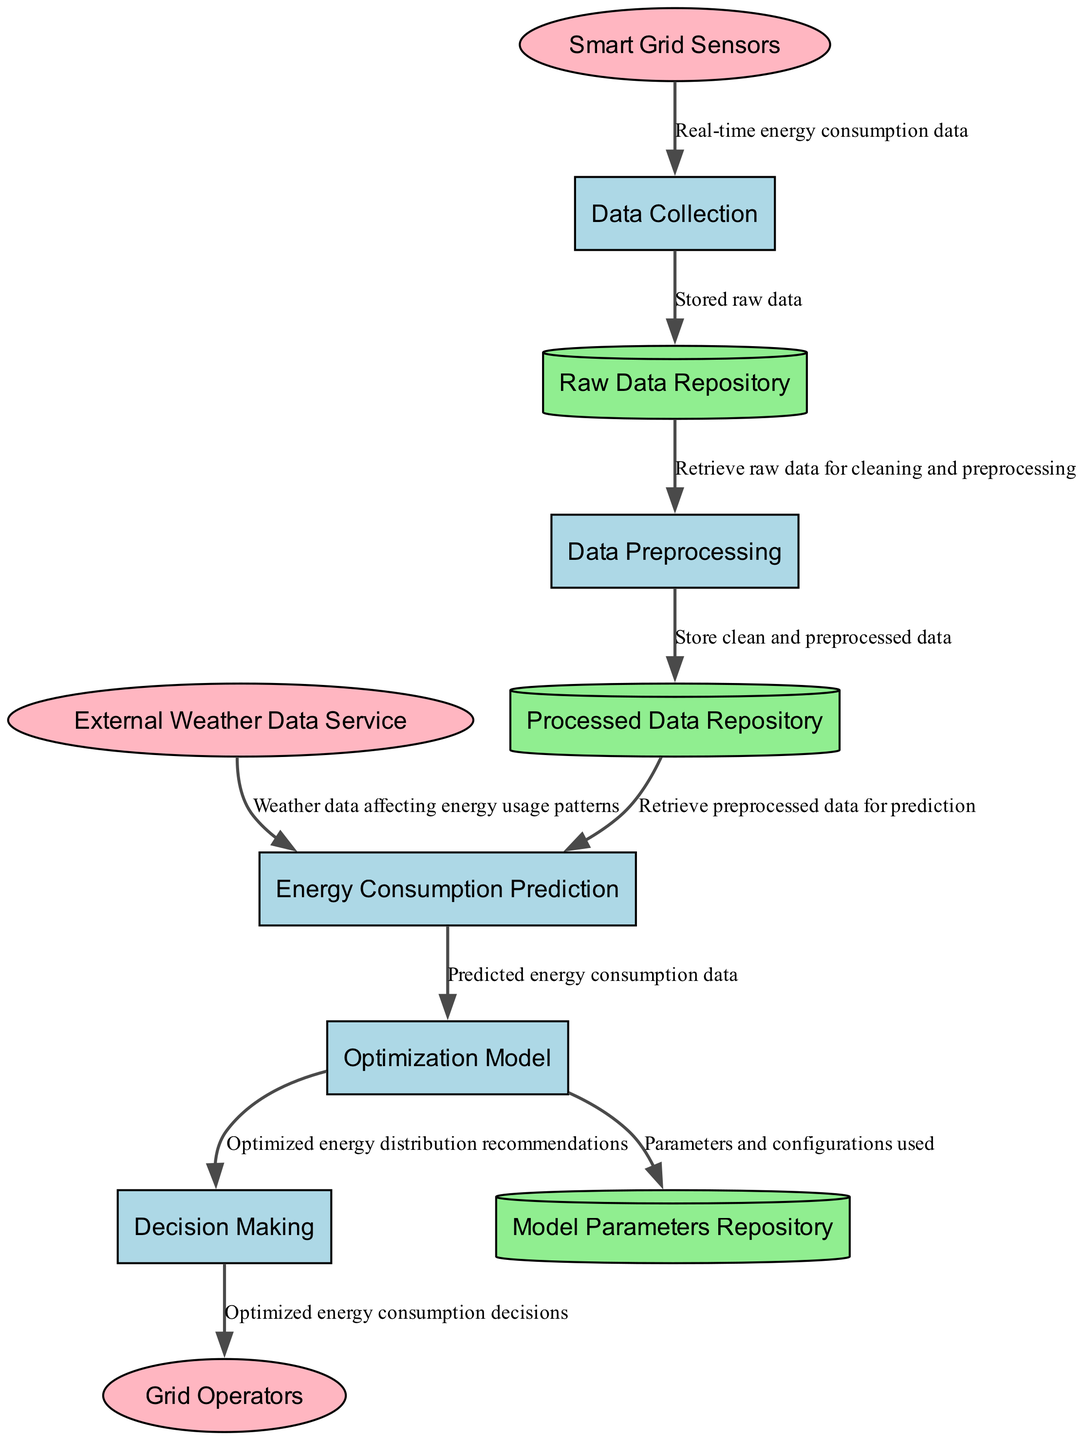What processes are included in the diagram? The diagram lists five processes: Data Collection, Data Preprocessing, Energy Consumption Prediction, Optimization Model, and Decision Making.
Answer: Data Collection, Data Preprocessing, Energy Consumption Prediction, Optimization Model, Decision Making How many data stores are present in the diagram? There are three data stores: Raw Data Repository, Processed Data Repository, and Model Parameters Repository. Therefore, the count is three.
Answer: 3 Which external entity provides real-time data input? The Smart Grid Sensors are identified as the external entity that provides real-time data input regarding energy consumption and grid status.
Answer: Smart Grid Sensors What does the Optimization Model use as input? The Optimization Model receives input from the Energy Consumption Prediction process, specifically using the predicted energy consumption data.
Answer: Predicted energy consumption data What is the relationship between the Decision Making and Grid Operators? The Decision Making process generates optimized energy consumption decisions that are sent to the Grid Operators, indicating a direct output to their operational decisions.
Answer: Optimized energy consumption decisions What are the data flows from the Data Preprocessing process? From the Data Preprocessing process, two data flows are identified: one to the Processed Data Repository (storing clean data) and another to the Energy Consumption Prediction process (providing preprocessed data for prediction).
Answer: To Processed Data Repository and to Energy Consumption Prediction What data does the Energy Consumption Prediction process retrieve? It retrieves preprocessed data from the Processed Data Repository that has been cleaned and is ready for further analysis.
Answer: Preprocessed data Which external entity affects energy usage patterns? The External Weather Data Service provides weather data that impacts energy consumption patterns, thereby influencing the overall prediction of energy demands.
Answer: External Weather Data Service How is the relationship between the Optimization Model and Model Parameters Repository characterized? The Optimization Model sends parameters and configurations to the Model Parameters Repository for storage, indicating that it uses specific values that require documentation.
Answer: Parameters and configurations used 